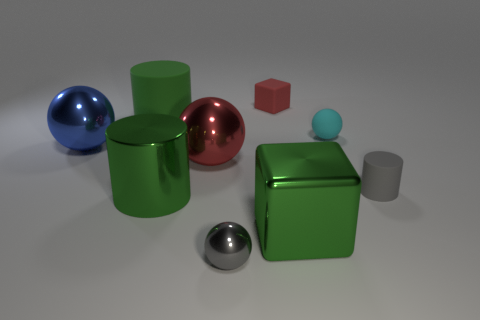How many green cylinders must be subtracted to get 1 green cylinders? 1 Subtract all balls. How many objects are left? 5 Subtract 0 yellow cylinders. How many objects are left? 9 Subtract all small yellow metal cylinders. Subtract all small gray metal spheres. How many objects are left? 8 Add 7 green objects. How many green objects are left? 10 Add 1 red blocks. How many red blocks exist? 2 